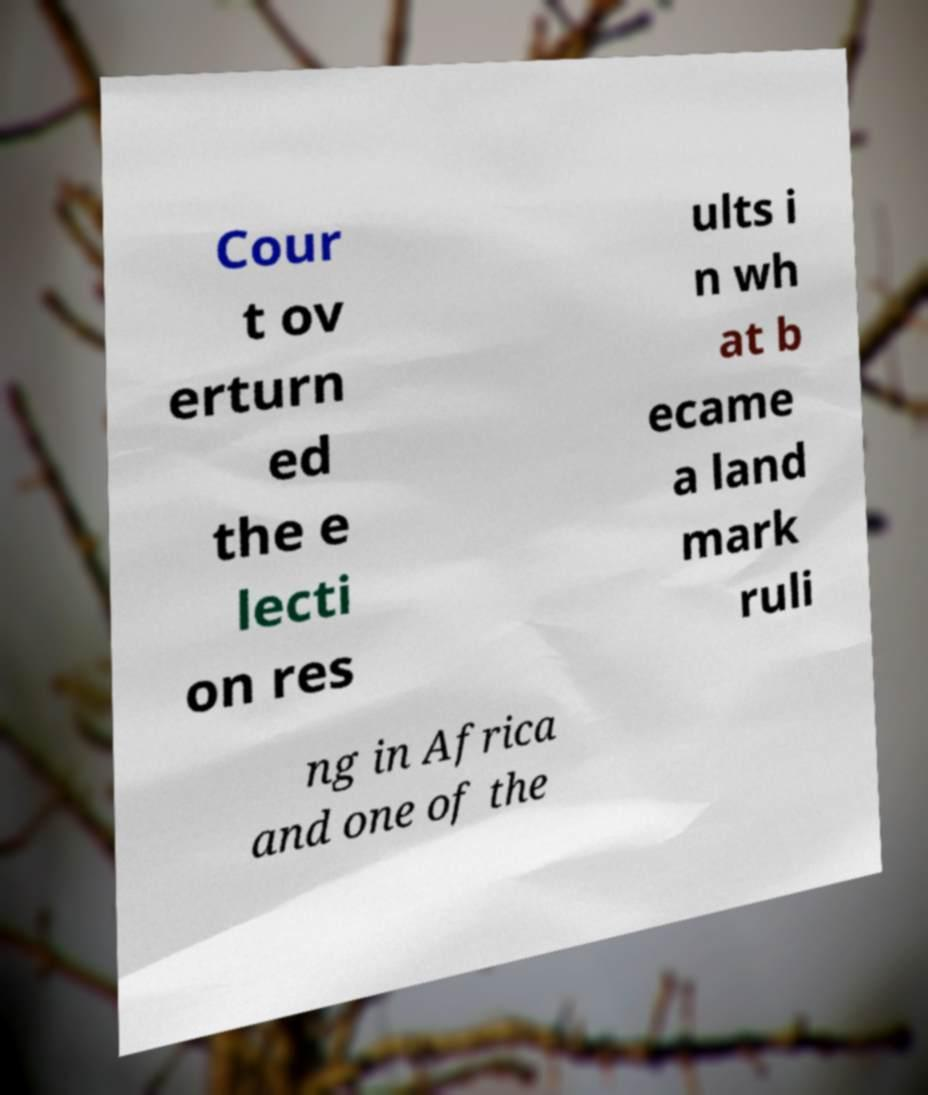Please identify and transcribe the text found in this image. Cour t ov erturn ed the e lecti on res ults i n wh at b ecame a land mark ruli ng in Africa and one of the 